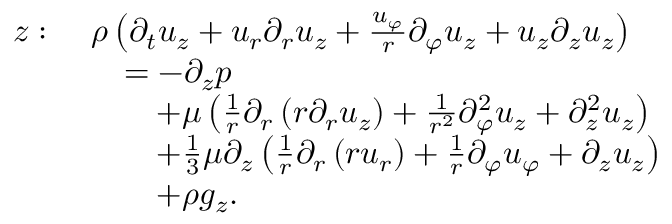Convert formula to latex. <formula><loc_0><loc_0><loc_500><loc_500>{ \begin{array} { r l } { z \colon \ } & { \rho \left ( { \partial _ { t } u _ { z } } + u _ { r } { \partial _ { r } u _ { z } } + { \frac { u _ { \varphi } } { r } } { \partial _ { \varphi } u _ { z } } + u _ { z } { \partial _ { z } u _ { z } } \right ) } \\ & { \quad = - { \partial _ { z } p } } \\ & { \quad + \mu \left ( { \frac { 1 } { r } } \partial _ { r } \left ( r { \partial _ { r } u _ { z } } \right ) + { \frac { 1 } { r ^ { 2 } } } { \partial _ { \varphi } ^ { 2 } u _ { z } } + { \partial _ { z } ^ { 2 } u _ { z } } \right ) } \\ & { \quad + { \frac { 1 } { 3 } } \mu \partial _ { z } \left ( { \frac { 1 } { r } } { \partial _ { r } \left ( r u _ { r } \right ) } + { \frac { 1 } { r } } { \partial _ { \varphi } u _ { \varphi } } + { \partial _ { z } u _ { z } } \right ) } \\ & { \quad + \rho g _ { z } . } \end{array} }</formula> 